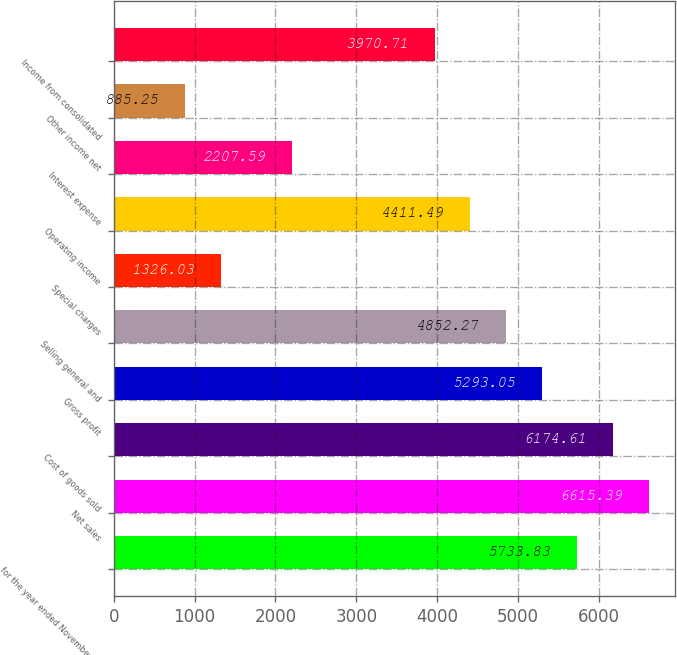Convert chart. <chart><loc_0><loc_0><loc_500><loc_500><bar_chart><fcel>for the year ended November 30<fcel>Net sales<fcel>Cost of goods sold<fcel>Gross profit<fcel>Selling general and<fcel>Special charges<fcel>Operating income<fcel>Interest expense<fcel>Other income net<fcel>Income from consolidated<nl><fcel>5733.83<fcel>6615.39<fcel>6174.61<fcel>5293.05<fcel>4852.27<fcel>1326.03<fcel>4411.49<fcel>2207.59<fcel>885.25<fcel>3970.71<nl></chart> 